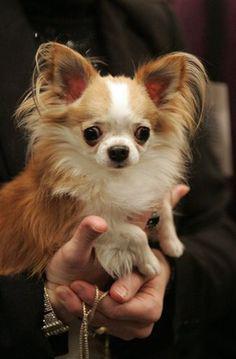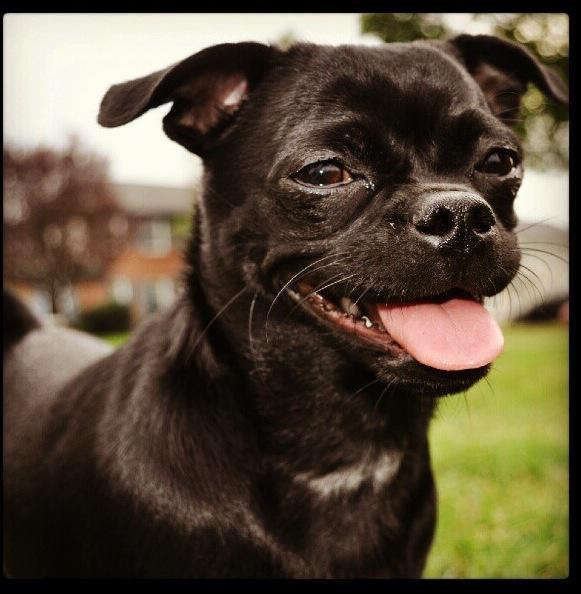The first image is the image on the left, the second image is the image on the right. Analyze the images presented: Is the assertion "An image shows two small chihuahuas, one on each side of a male person facing the camera." valid? Answer yes or no. No. The first image is the image on the left, the second image is the image on the right. Considering the images on both sides, is "The right image contains exactly two dogs." valid? Answer yes or no. No. 